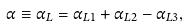<formula> <loc_0><loc_0><loc_500><loc_500>\alpha \equiv \alpha _ { L } = \alpha _ { L 1 } + \alpha _ { L 2 } - \alpha _ { L 3 } ,</formula> 